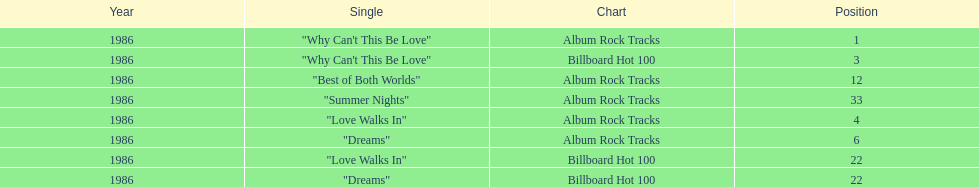Which is the most popular single on the album? Why Can't This Be Love. 